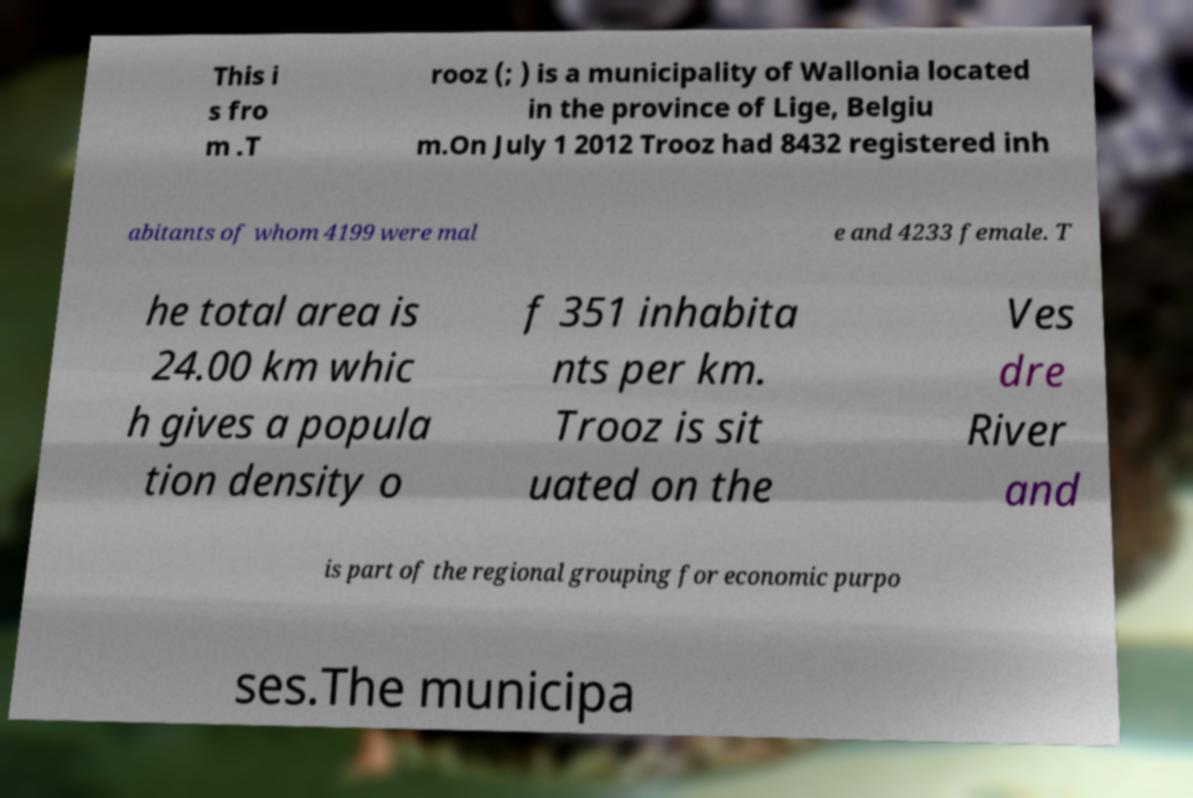I need the written content from this picture converted into text. Can you do that? This i s fro m .T rooz (; ) is a municipality of Wallonia located in the province of Lige, Belgiu m.On July 1 2012 Trooz had 8432 registered inh abitants of whom 4199 were mal e and 4233 female. T he total area is 24.00 km whic h gives a popula tion density o f 351 inhabita nts per km. Trooz is sit uated on the Ves dre River and is part of the regional grouping for economic purpo ses.The municipa 